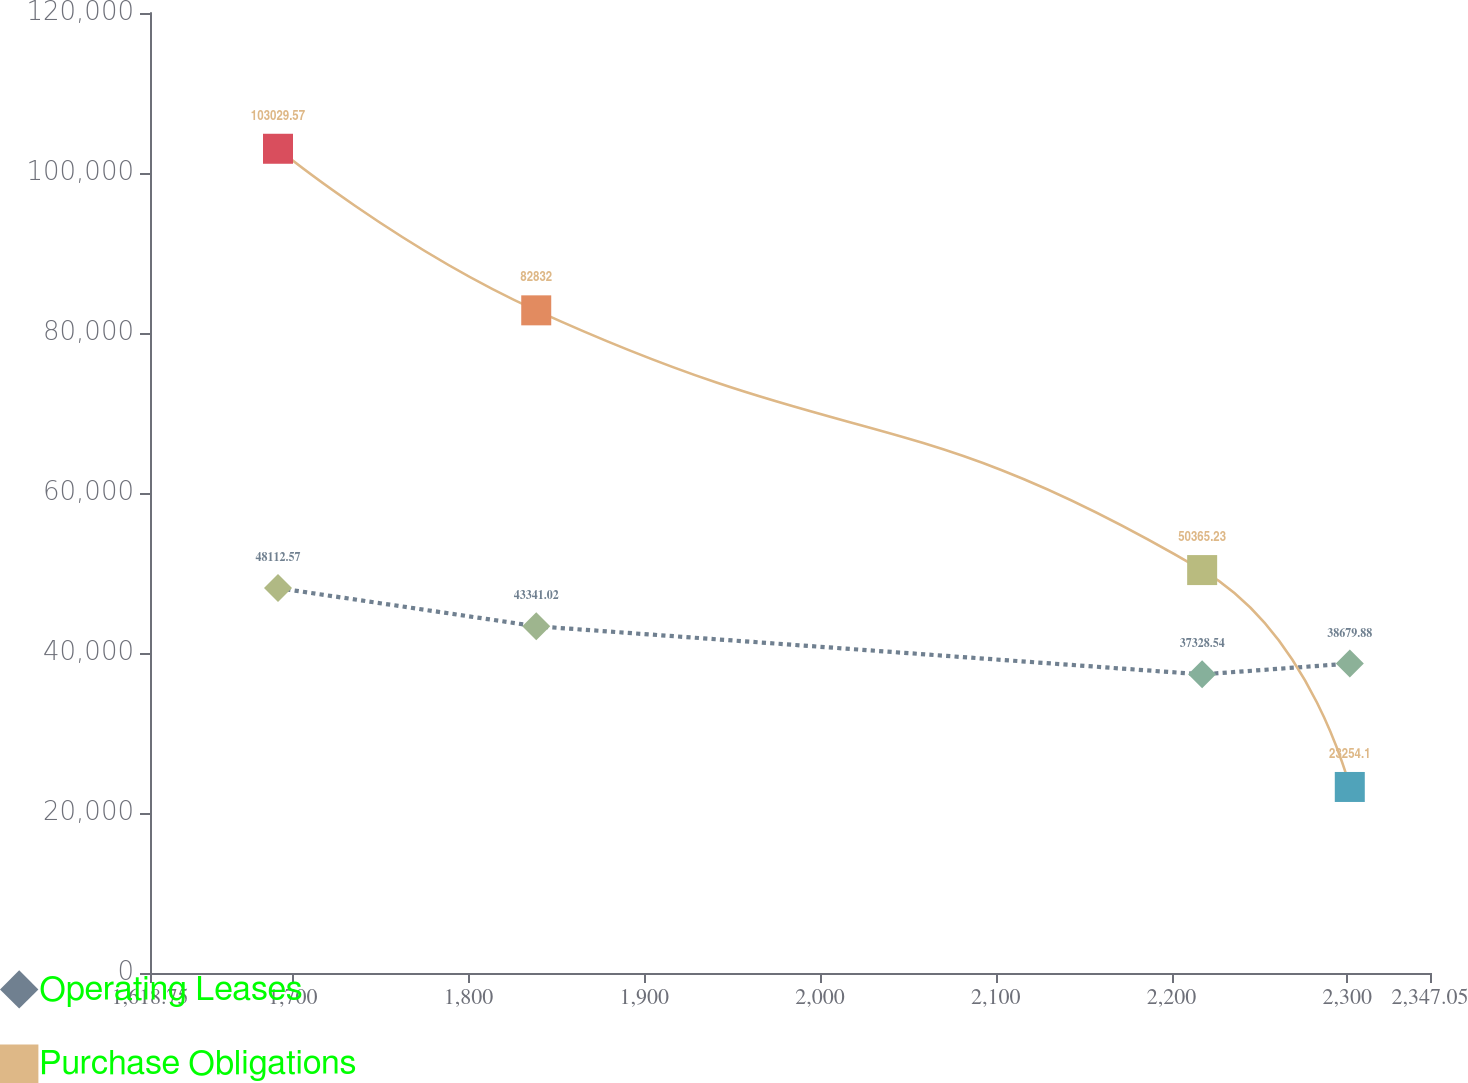Convert chart. <chart><loc_0><loc_0><loc_500><loc_500><line_chart><ecel><fcel>Operating Leases<fcel>Purchase Obligations<nl><fcel>1691.58<fcel>48112.6<fcel>103030<nl><fcel>1838.51<fcel>43341<fcel>82832<nl><fcel>2217.41<fcel>37328.5<fcel>50365.2<nl><fcel>2301.41<fcel>38679.9<fcel>23254.1<nl><fcel>2419.88<fcel>36130.3<fcel>31231.7<nl></chart> 